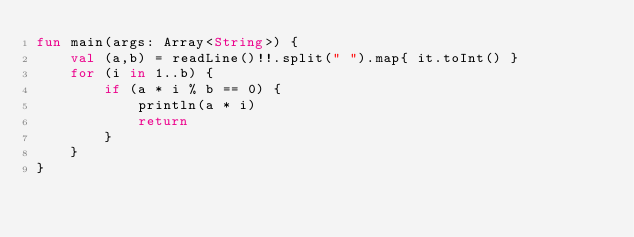<code> <loc_0><loc_0><loc_500><loc_500><_Kotlin_>fun main(args: Array<String>) {
    val (a,b) = readLine()!!.split(" ").map{ it.toInt() }
    for (i in 1..b) {
        if (a * i % b == 0) {
            println(a * i)
            return
        }
    }
}</code> 